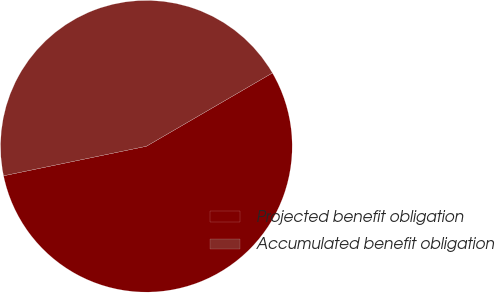Convert chart. <chart><loc_0><loc_0><loc_500><loc_500><pie_chart><fcel>Projected benefit obligation<fcel>Accumulated benefit obligation<nl><fcel>55.14%<fcel>44.86%<nl></chart> 